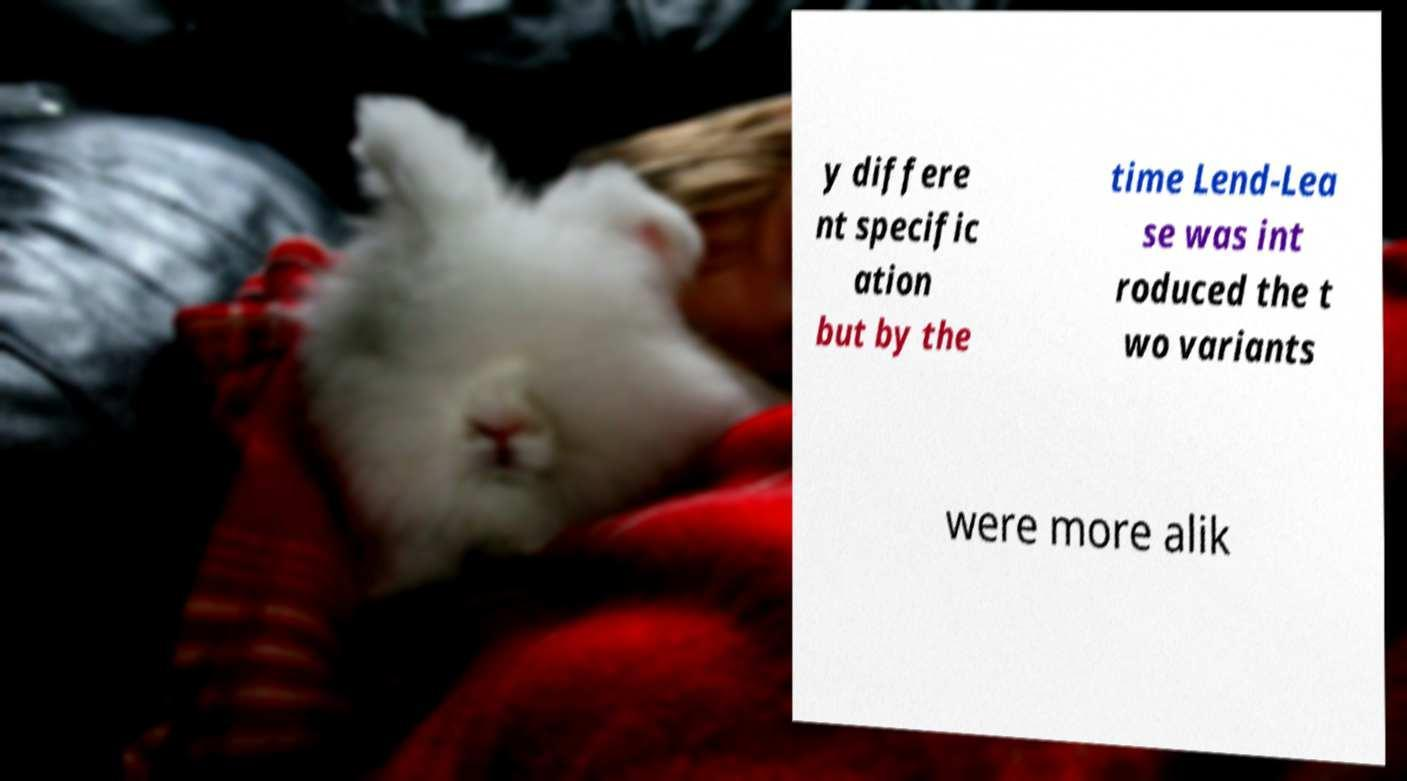For documentation purposes, I need the text within this image transcribed. Could you provide that? y differe nt specific ation but by the time Lend-Lea se was int roduced the t wo variants were more alik 